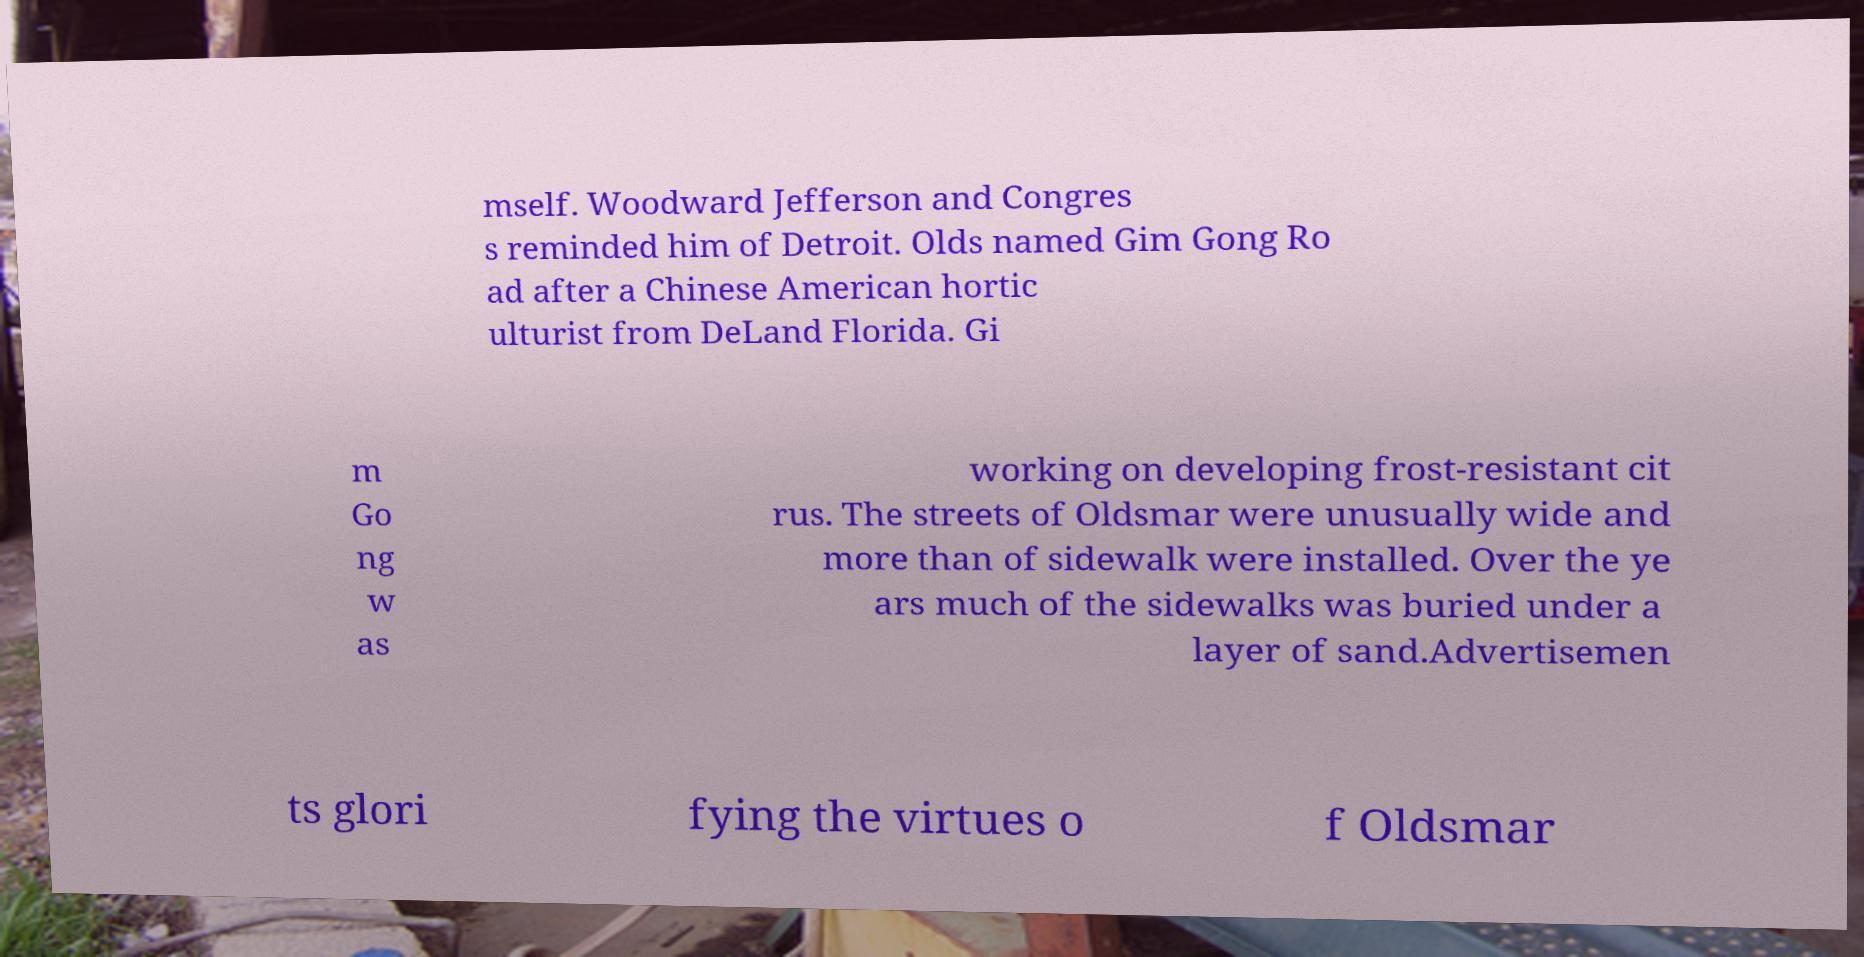For documentation purposes, I need the text within this image transcribed. Could you provide that? mself. Woodward Jefferson and Congres s reminded him of Detroit. Olds named Gim Gong Ro ad after a Chinese American hortic ulturist from DeLand Florida. Gi m Go ng w as working on developing frost-resistant cit rus. The streets of Oldsmar were unusually wide and more than of sidewalk were installed. Over the ye ars much of the sidewalks was buried under a layer of sand.Advertisemen ts glori fying the virtues o f Oldsmar 